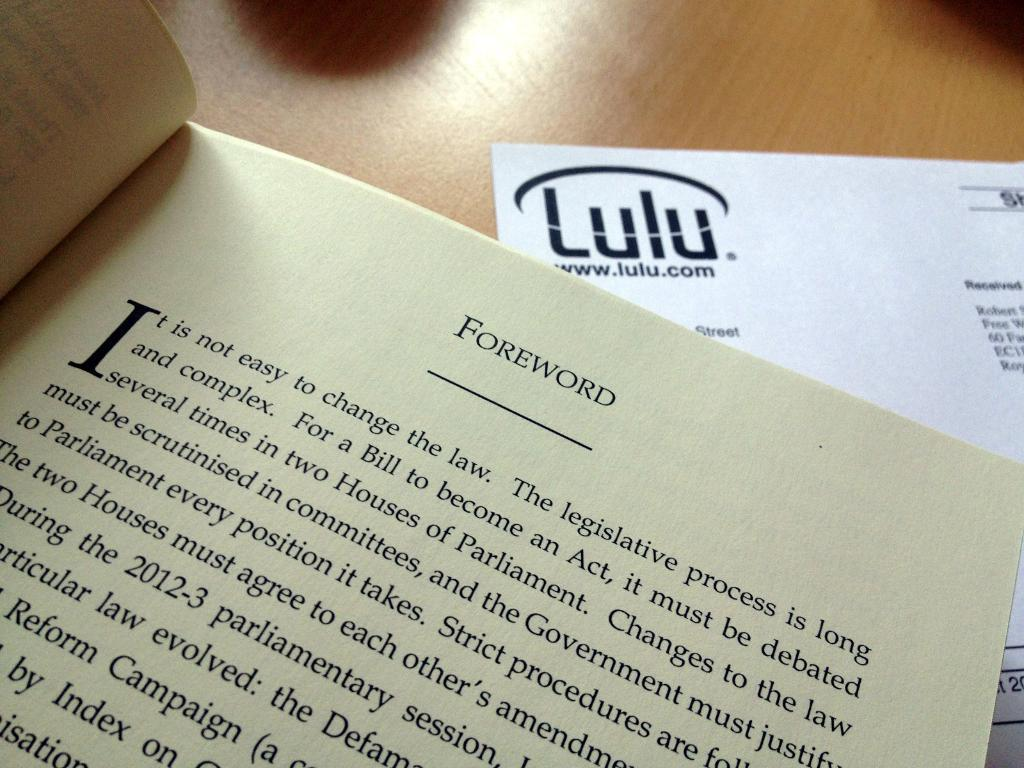What is one object that can be seen in the image? There is a book in the image. What other item is present in the image? There is a paper in the image. Can you describe any additional details about the image? There are shadows visible on the table in the image. How does the book rub against the paper in the image? There is no indication in the image that the book is rubbing against the paper. 